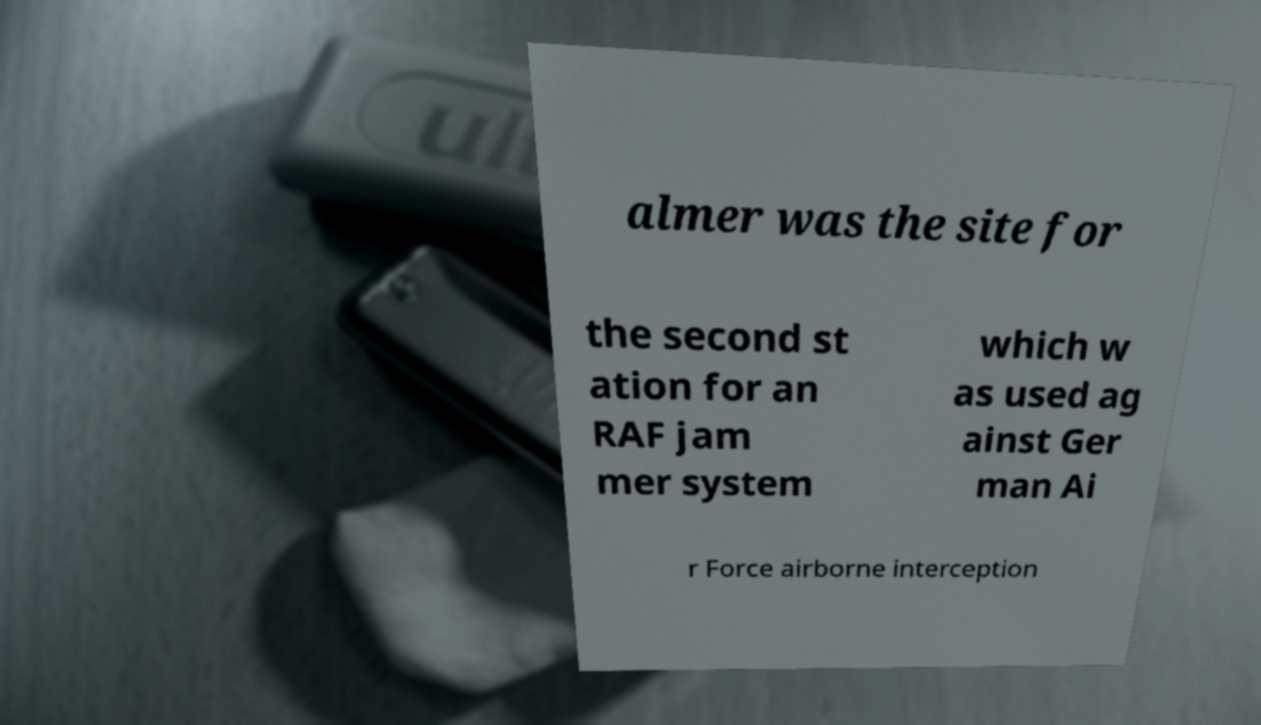Could you extract and type out the text from this image? almer was the site for the second st ation for an RAF jam mer system which w as used ag ainst Ger man Ai r Force airborne interception 